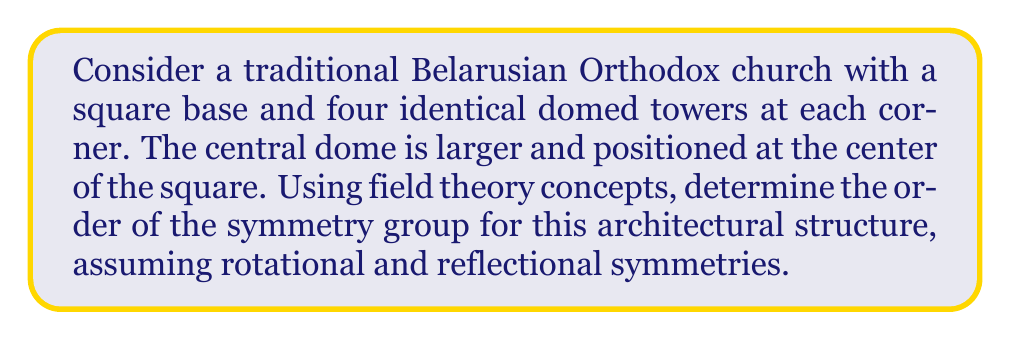Help me with this question. Let's approach this step-by-step using concepts from field theory and group theory:

1) First, we need to identify the symmetries of the structure:
   - Rotational symmetry: The church has 4-fold rotational symmetry (90° rotations).
   - Reflectional symmetry: There are 4 lines of reflection (2 diagonals and 2 medians).

2) In field theory, we can consider these symmetries as elements of a finite group acting on the field of real numbers $\mathbb{R}^2$ (representing the 2D plane of the church's base).

3) Let's count the elements of this group:
   - Identity transformation: 1
   - Rotations: 3 (90°, 180°, 270°)
   - Reflections: 4 (along 2 diagonals and 2 medians)

4) The total number of elements in the symmetry group is thus 1 + 3 + 4 = 8.

5) This group is isomorphic to the dihedral group $D_4$, which can be represented as:

   $$D_4 = \{e, r, r^2, r^3, s, sr, sr^2, sr^3\}$$

   where $e$ is the identity, $r$ is a 90° rotation, and $s$ is a reflection.

6) The order of a group in field theory is the number of elements in the group. Therefore, the order of this symmetry group is 8.

7) In the context of field theory, this symmetry group forms a Galois group over the field of real numbers, preserving the geometric structure of the church.
Answer: 8 